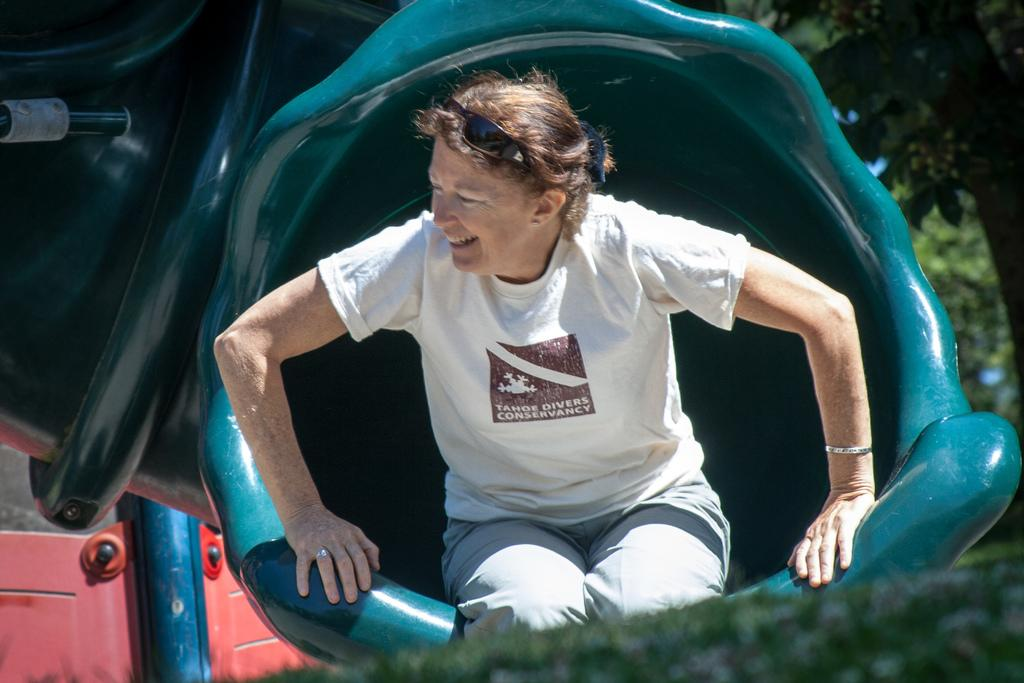Who is present in the image? There is a woman in the image. What is the woman wearing? The woman is wearing clothes, a finger ring, and a bracelet. What is the woman doing in the image? The woman is sitting. What objects can be seen in the image? There is an object and goggles in the image. What type of vegetation is visible in the image? There is a tree in the image. What type of island can be seen in the image? There is no island present in the image. What design is featured on the cup in the image? There is no cup present in the image. 